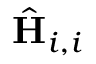<formula> <loc_0><loc_0><loc_500><loc_500>\hat { H } _ { i , i }</formula> 